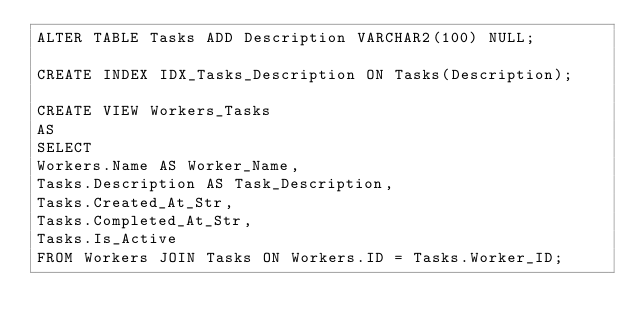Convert code to text. <code><loc_0><loc_0><loc_500><loc_500><_SQL_>ALTER TABLE Tasks ADD Description VARCHAR2(100) NULL;

CREATE INDEX IDX_Tasks_Description ON Tasks(Description);

CREATE VIEW Workers_Tasks
AS
SELECT
Workers.Name AS Worker_Name,
Tasks.Description AS Task_Description,
Tasks.Created_At_Str,
Tasks.Completed_At_Str,
Tasks.Is_Active
FROM Workers JOIN Tasks ON Workers.ID = Tasks.Worker_ID;
</code> 